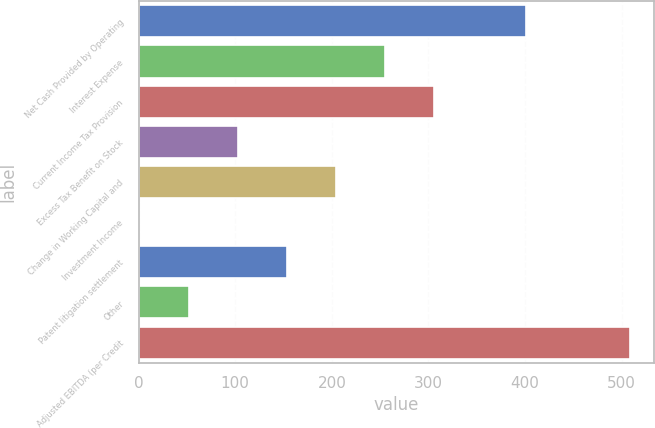Convert chart to OTSL. <chart><loc_0><loc_0><loc_500><loc_500><bar_chart><fcel>Net Cash Provided by Operating<fcel>Interest Expense<fcel>Current Income Tax Provision<fcel>Excess Tax Benefit on Stock<fcel>Change in Working Capital and<fcel>Investment Income<fcel>Patent litigation settlement<fcel>Other<fcel>Adjusted EBITDA (per Credit<nl><fcel>400.9<fcel>254.95<fcel>305.68<fcel>102.76<fcel>204.22<fcel>1.3<fcel>153.49<fcel>52.03<fcel>508.6<nl></chart> 